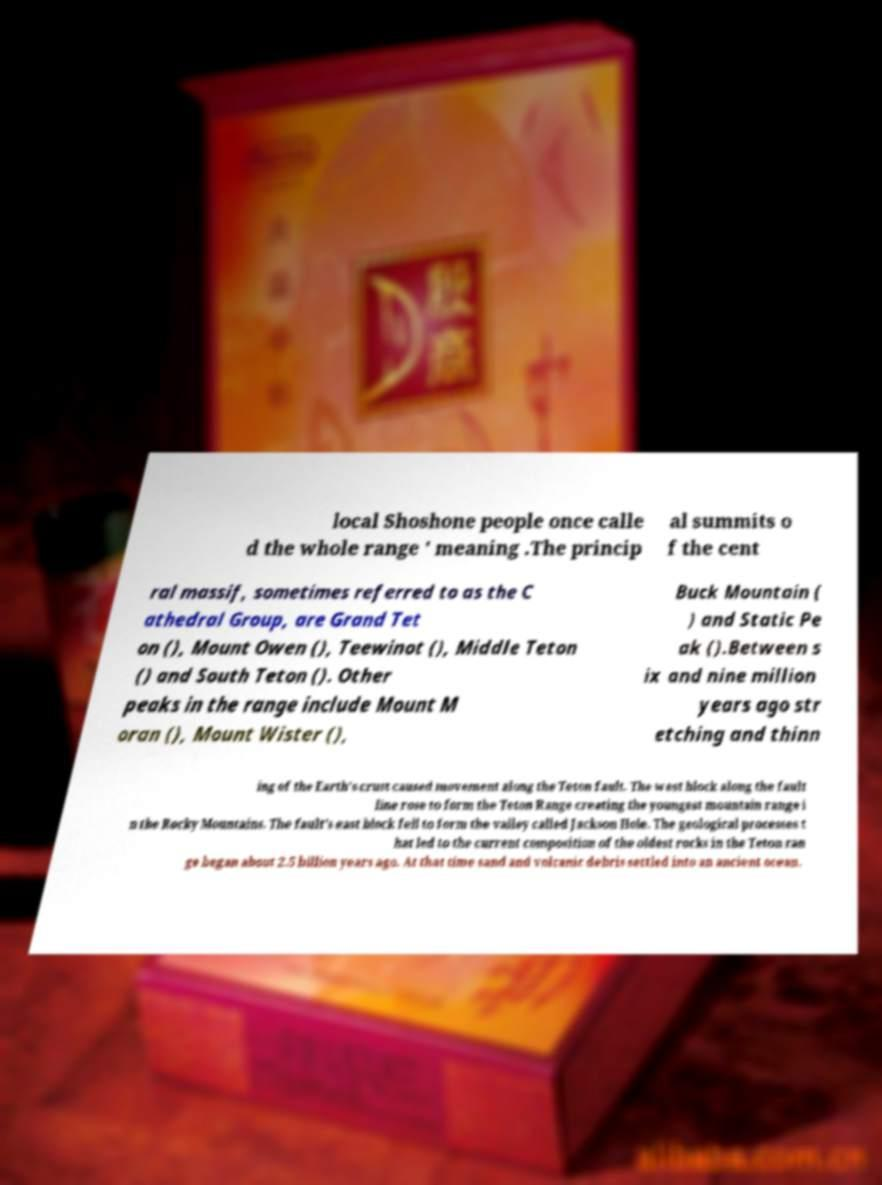Please read and relay the text visible in this image. What does it say? local Shoshone people once calle d the whole range ' meaning .The princip al summits o f the cent ral massif, sometimes referred to as the C athedral Group, are Grand Tet on (), Mount Owen (), Teewinot (), Middle Teton () and South Teton (). Other peaks in the range include Mount M oran (), Mount Wister (), Buck Mountain ( ) and Static Pe ak ().Between s ix and nine million years ago str etching and thinn ing of the Earth's crust caused movement along the Teton fault. The west block along the fault line rose to form the Teton Range creating the youngest mountain range i n the Rocky Mountains. The fault's east block fell to form the valley called Jackson Hole. The geological processes t hat led to the current composition of the oldest rocks in the Teton ran ge began about 2.5 billion years ago. At that time sand and volcanic debris settled into an ancient ocean. 